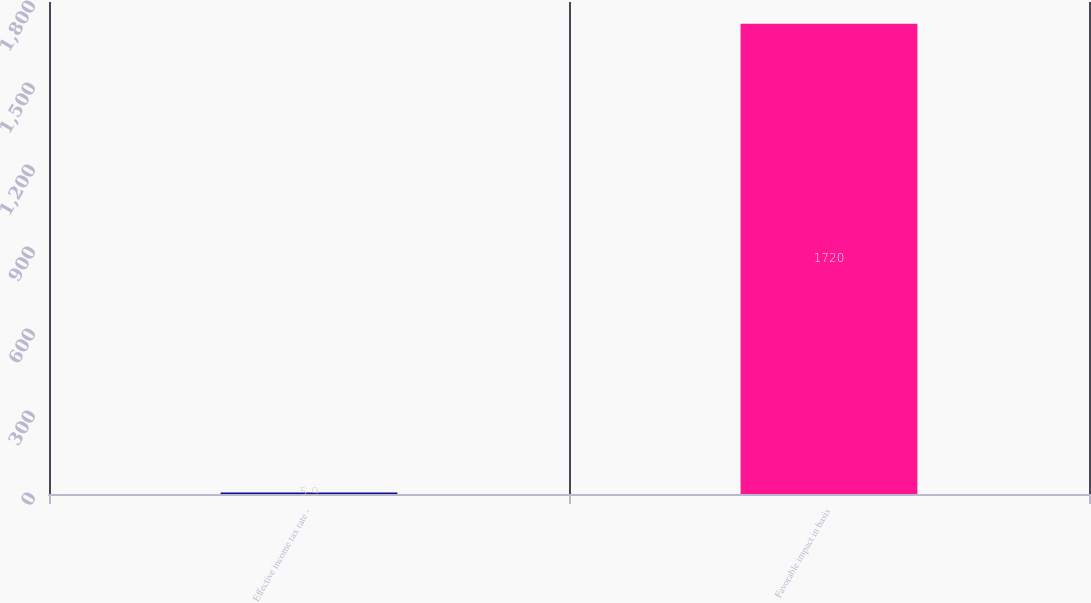Convert chart to OTSL. <chart><loc_0><loc_0><loc_500><loc_500><bar_chart><fcel>Effective income tax rate -<fcel>Favorable impact in basis<nl><fcel>5.9<fcel>1720<nl></chart> 